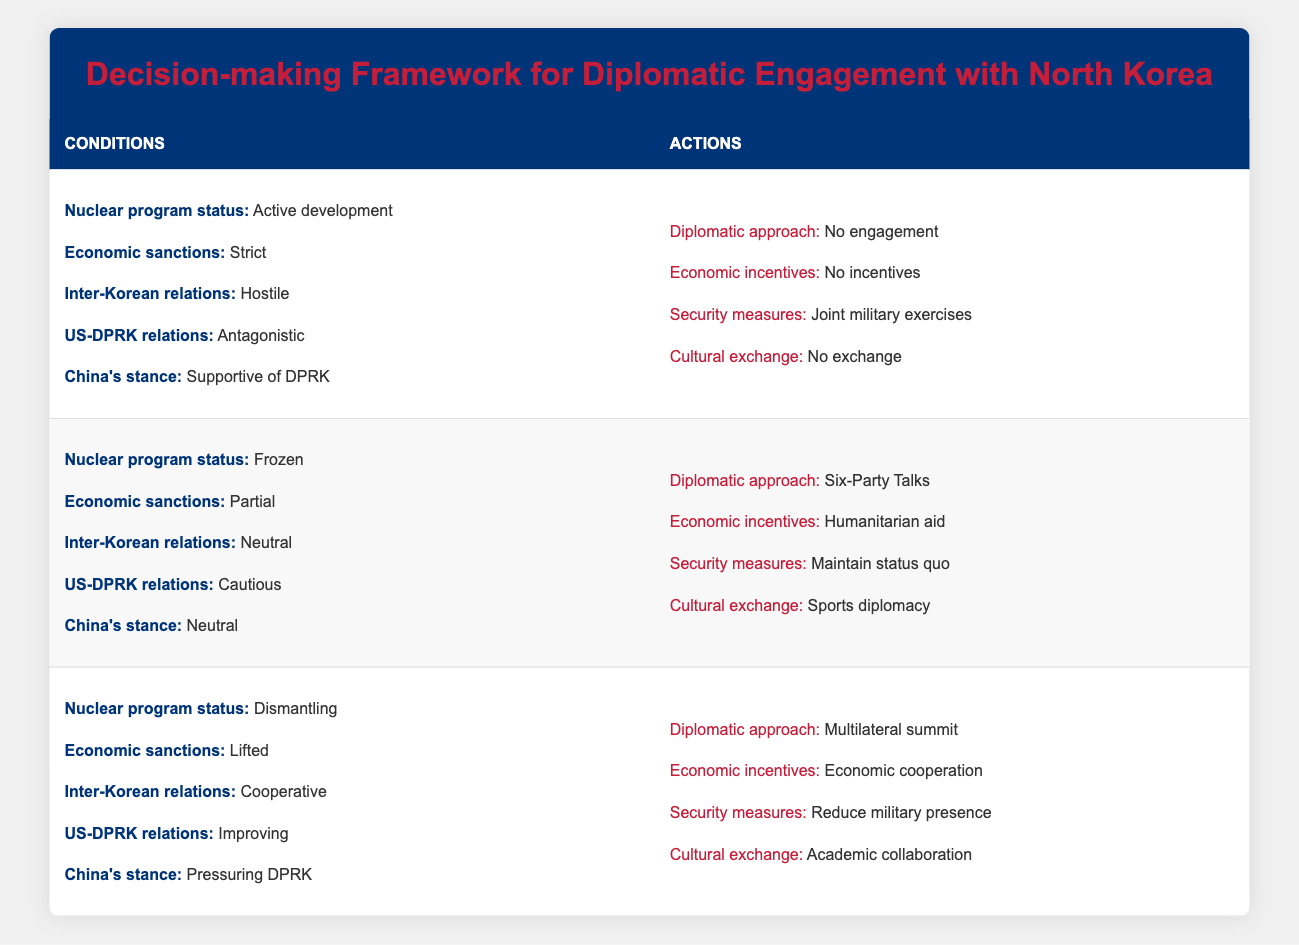What is the diplomatic approach when the nuclear program status is 'Active development'? According to the table, when the nuclear program status is 'Active development', the recommended diplomatic approach is 'No engagement'.
Answer: No engagement What are the economic incentives recommended when inter-Korean relations are 'Neutral'? From the table, when inter-Korean relations are categorized as 'Neutral', the recommended economic incentive is 'Humanitarian aid'.
Answer: Humanitarian aid Are security measures maintained when the economic sanctions are 'Lifted'? The table indicates under the conditions of 'Lifted' economic sanctions, the recommended security measure is 'Reduce military presence', which means security measures are not maintained.
Answer: No What is the combined diplomatic approach if the nuclear program is 'Frozen', and US-DPRK relations are 'Cautious'? When the nuclear program is 'Frozen' and US-DPRK relations are 'Cautious', the table specifies the diplomatic approach as 'Six-Party Talks'.
Answer: Six-Party Talks Under what conditions would 'Cultural exchange' be 'Academic collaboration'? According to the rules, 'Cultural exchange' would be 'Academic collaboration' when the nuclear program is 'Dismantling', economic sanctions are 'Lifted', inter-Korean relations are 'Cooperative', US-DPRK relations are 'Improving', and China's stance is 'Pressuring DPRK'.
Answer: Dismantling, Lifted, Cooperative, Improving, Pressuring DPRK What is the average number of actions specified for each set of conditions? There are 3 sets of conditions with 4 actions each, totaling 12 actions. Dividing this by 3 gives an average of 4 actions per set of conditions.
Answer: 4 If inter-Korean relations are 'Hostile', what kind of economic incentives are suggested? The table shows that when inter-Korean relations are 'Hostile', the economic incentives are 'No incentives'.
Answer: No incentives Is there any situation in which 'Bilateral negotiations' is the chosen diplomatic approach? Reviewing the table, there are no conditions listed for which 'Bilateral negotiations' is recommended. Therefore, it is not a chosen approach.
Answer: No 